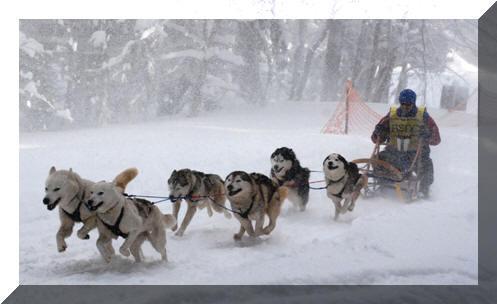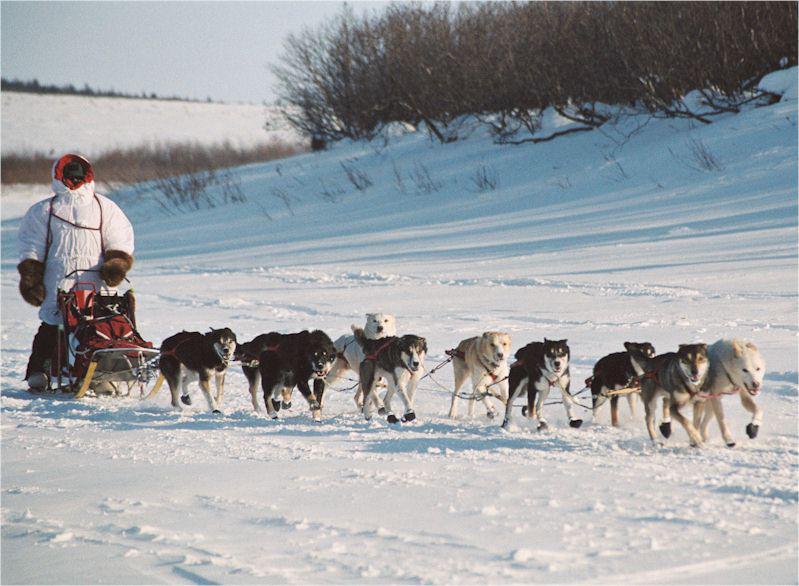The first image is the image on the left, the second image is the image on the right. Assess this claim about the two images: "Each image shows a sled driver behind a team of dogs moving forward over snow, and a lead dog wears black booties in the team on the right.". Correct or not? Answer yes or no. Yes. 